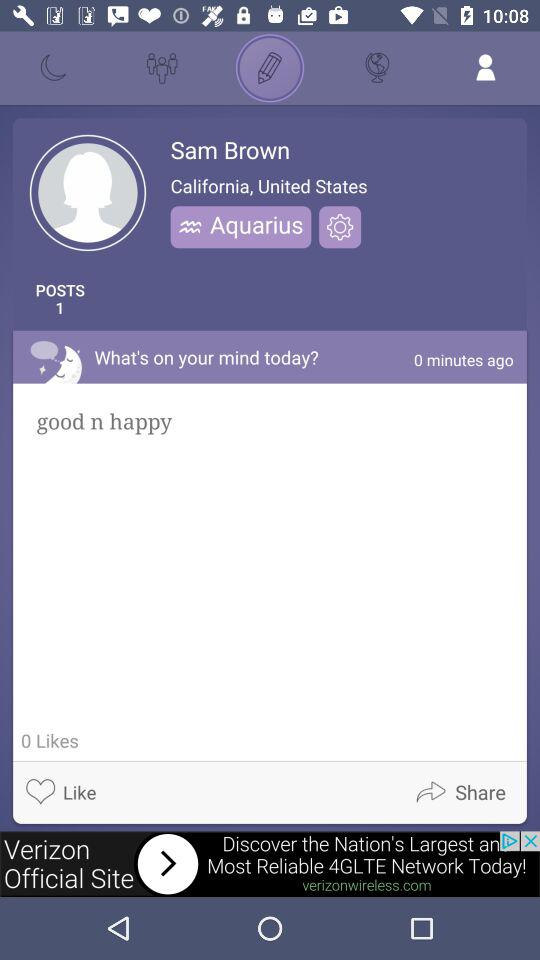What is the given location? The given location is California, United States. 